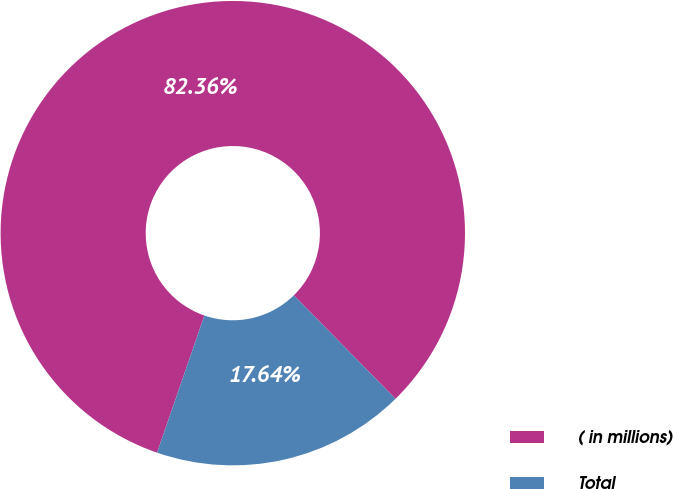<chart> <loc_0><loc_0><loc_500><loc_500><pie_chart><fcel>( in millions)<fcel>Total<nl><fcel>82.36%<fcel>17.64%<nl></chart> 